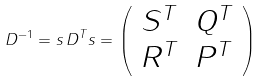<formula> <loc_0><loc_0><loc_500><loc_500>D ^ { - 1 } = s \, D ^ { T } s = \left ( \begin{array} { c c } S ^ { T } & Q ^ { T } \\ R ^ { T } & P ^ { T } \end{array} \right )</formula> 